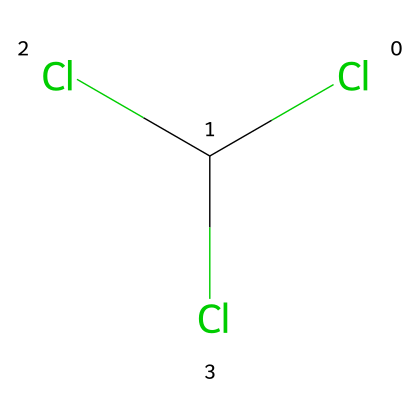What is the molecular formula of chloroform? The SMILES representation ClC(Cl)Cl indicates there are one carbon (C) and three chlorine (Cl) atoms, leading to the molecular formula CCl3.
Answer: CCl3 How many chlorine atoms are present in chloroform? The SMILES representation shows three chlorine atoms attached to a single carbon atom, as indicated by the three Cl symbols.
Answer: 3 What is the primary use of chloroform historically? Chloroform has been used primarily as an anesthetic in medical procedures for its ability to induce unconsciousness.
Answer: anesthetic Which functional group is prominent in chloroform? The presence of chlorine atoms attached to a carbon atom indicates that chlorinated hydrocarbons characterize chloroform, making it a member of this functional group type.
Answer: chlorinated hydrocarbon How does the structure of chloroform influence its physical properties? Chloroform's molecular structure, with three chlorine atoms contributing to its polar nature, affects its boiling point and solvent properties, making it effective for dissolving organic compounds.
Answer: polar solvent What type of solvent is chloroform classified as? Given its structure and properties, chloroform is commonly classified as an organic solvent, which is typically used for dissolving other organic materials.
Answer: organic solvent What implications does chloroform have regarding health regulations? Due to its historical use as an anesthetic and associated health risks, chloroform is regulated under various healthcare laws, especially concerning its exposure limits and usage in medical settings.
Answer: health regulations 